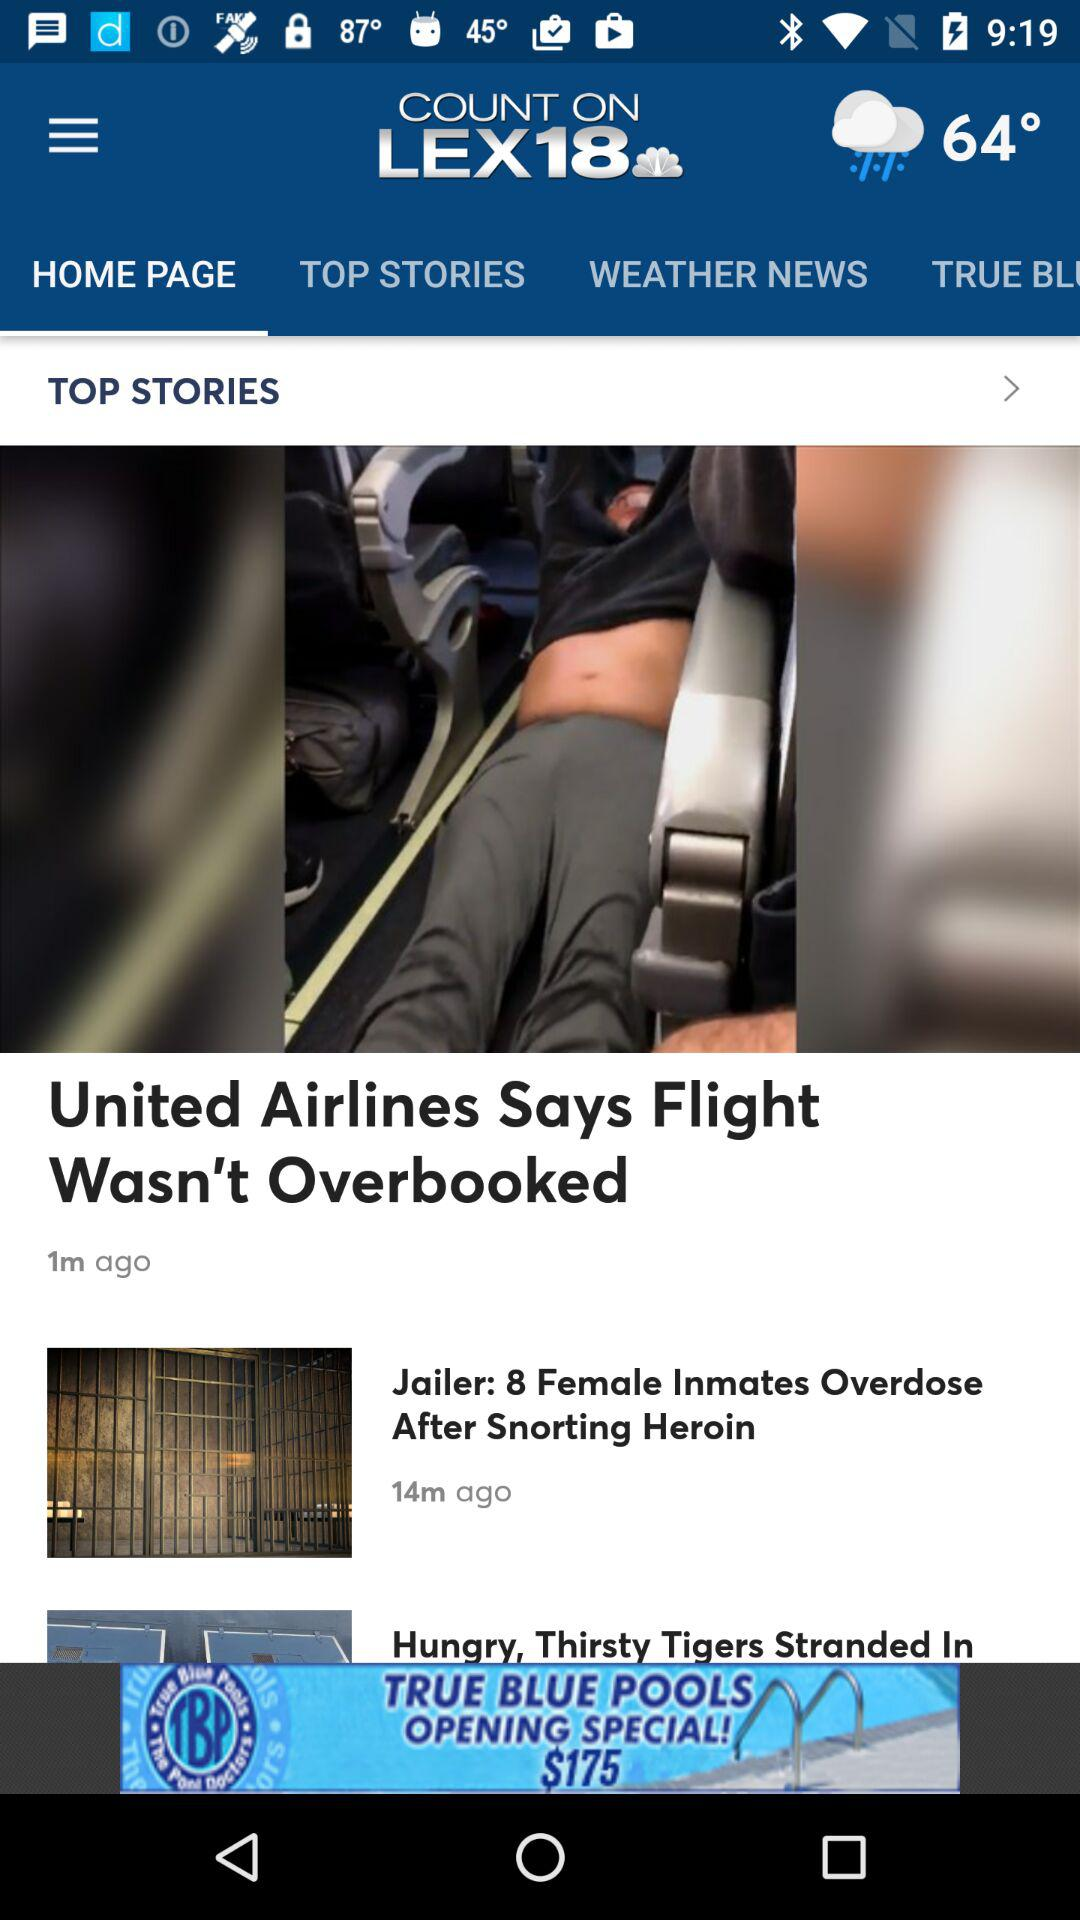Which tab is selected? The selected tab is "HOME PAGE". 